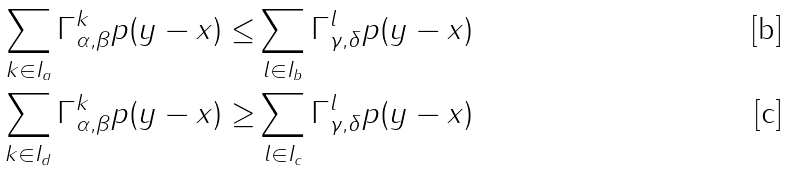Convert formula to latex. <formula><loc_0><loc_0><loc_500><loc_500>\sum _ { k \in I _ { a } } \Gamma _ { \alpha , \beta } ^ { k } p ( y - x ) \leq & \sum _ { l \in I _ { b } } \Gamma _ { \gamma , \delta } ^ { l } p ( y - x ) \\ \sum _ { k \in I _ { d } } \Gamma _ { \alpha , \beta } ^ { k } p ( y - x ) \geq & \sum _ { l \in I _ { c } } \Gamma _ { \gamma , \delta } ^ { l } p ( y - x )</formula> 